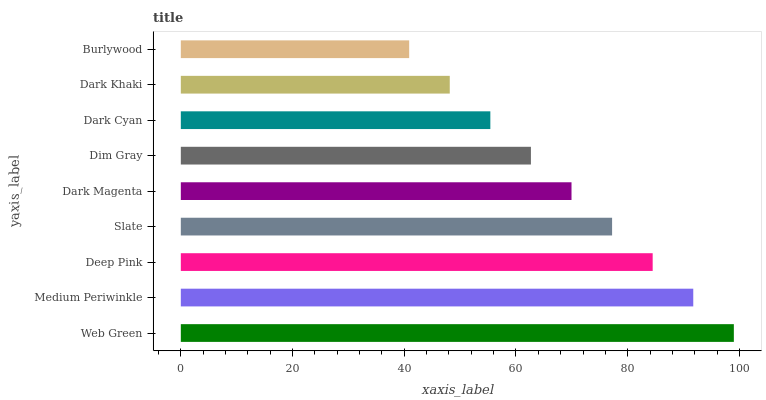Is Burlywood the minimum?
Answer yes or no. Yes. Is Web Green the maximum?
Answer yes or no. Yes. Is Medium Periwinkle the minimum?
Answer yes or no. No. Is Medium Periwinkle the maximum?
Answer yes or no. No. Is Web Green greater than Medium Periwinkle?
Answer yes or no. Yes. Is Medium Periwinkle less than Web Green?
Answer yes or no. Yes. Is Medium Periwinkle greater than Web Green?
Answer yes or no. No. Is Web Green less than Medium Periwinkle?
Answer yes or no. No. Is Dark Magenta the high median?
Answer yes or no. Yes. Is Dark Magenta the low median?
Answer yes or no. Yes. Is Medium Periwinkle the high median?
Answer yes or no. No. Is Burlywood the low median?
Answer yes or no. No. 